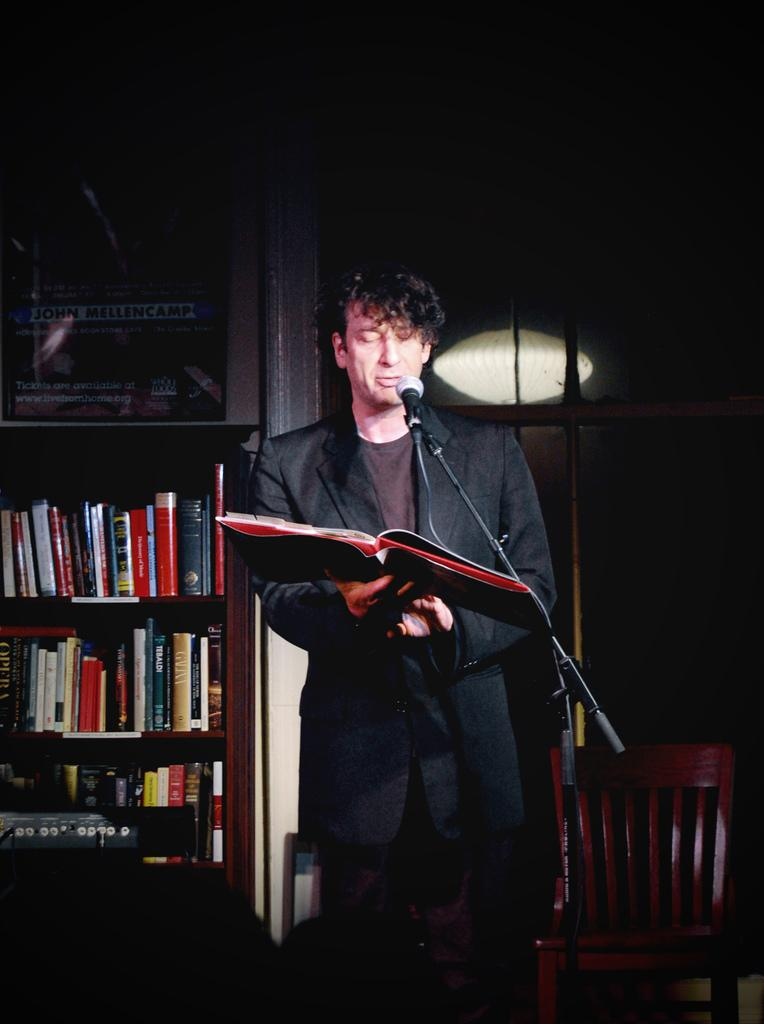What is the man in the image doing? The man is talking on a microphone. What else is the man holding in the image? The man is holding a book. What can be seen behind the man in the image? There is a rack with books in the image. What piece of furniture is present in the image? There is a chair in the image. What source of illumination is visible in the image? There is a light in the image. What shape is the tramp in the image? There is no tramp present in the image. What type of bed is visible in the image? There is no bed present in the image. 